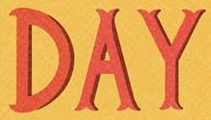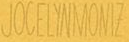Read the text content from these images in order, separated by a semicolon. DAY; JOCELYNMONIZ 